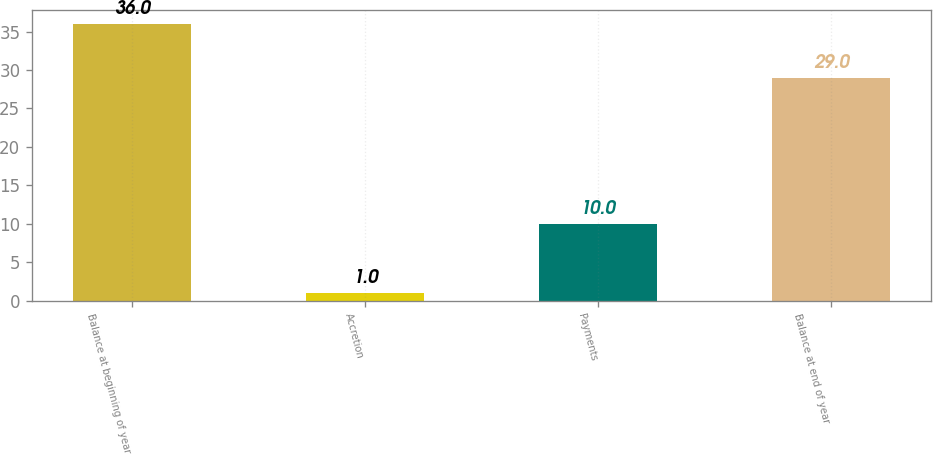Convert chart. <chart><loc_0><loc_0><loc_500><loc_500><bar_chart><fcel>Balance at beginning of year<fcel>Accretion<fcel>Payments<fcel>Balance at end of year<nl><fcel>36<fcel>1<fcel>10<fcel>29<nl></chart> 